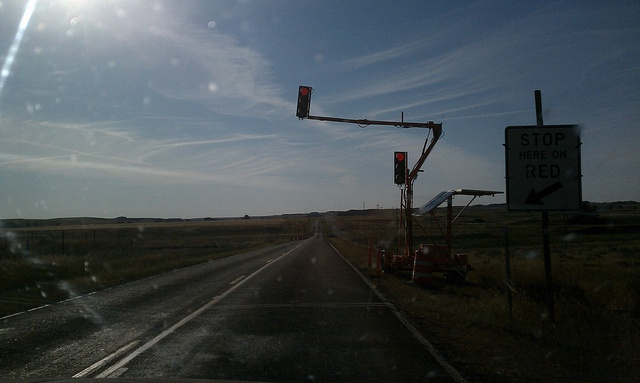Describe the objects in this image and their specific colors. I can see stop sign in darkgray, black, blue, and darkblue tones, traffic light in darkgray, black, maroon, and gray tones, and traffic light in darkgray, black, maroon, and gray tones in this image. 